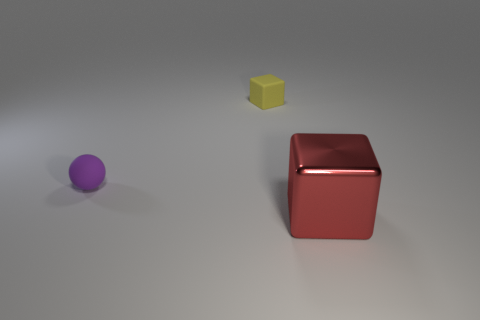Add 3 big purple balls. How many objects exist? 6 Subtract all balls. How many objects are left? 2 Add 2 tiny yellow matte things. How many tiny yellow matte things are left? 3 Add 3 yellow metal objects. How many yellow metal objects exist? 3 Subtract 0 cyan cubes. How many objects are left? 3 Subtract all large red shiny objects. Subtract all large yellow blocks. How many objects are left? 2 